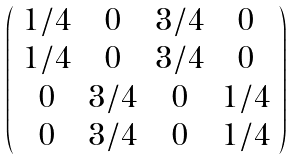Convert formula to latex. <formula><loc_0><loc_0><loc_500><loc_500>\left ( \begin{array} { c c c c } 1 / 4 & 0 & 3 / 4 & 0 \\ 1 / 4 & 0 & 3 / 4 & 0 \\ 0 & 3 / 4 & 0 & 1 / 4 \\ 0 & 3 / 4 & 0 & 1 / 4 \\ \end{array} \right )</formula> 